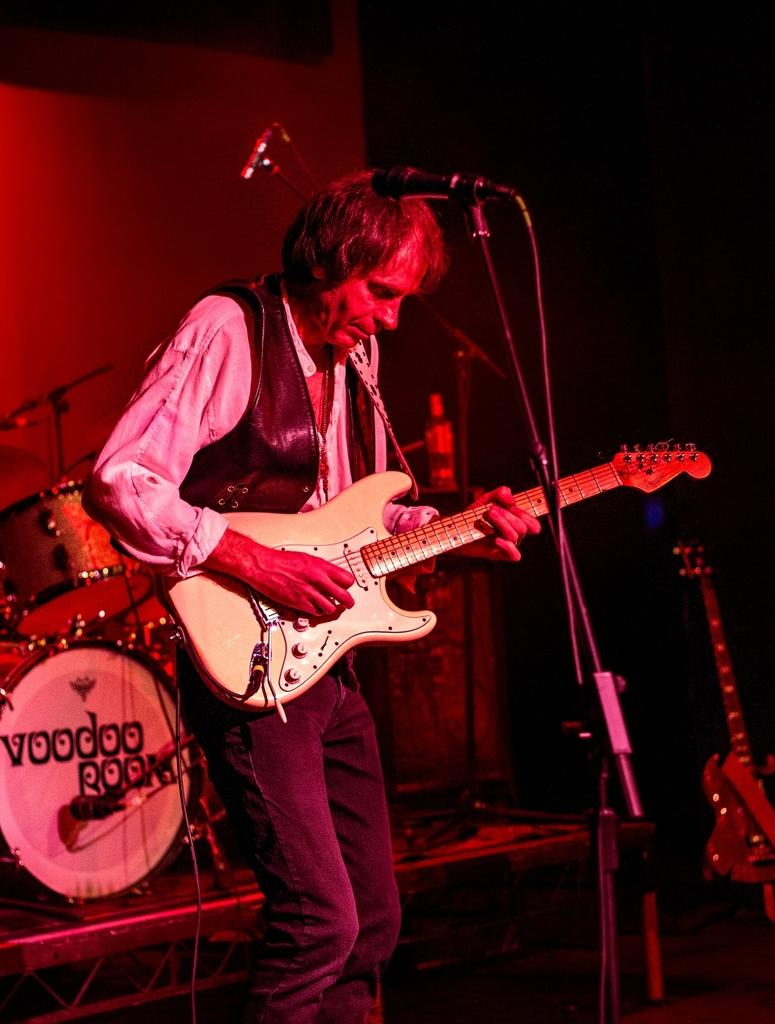Who is the main subject in the image? There is a man in the image. What is the man holding in the image? The man is holding a guitar. What is in front of the man in the image? There is a microphone with a mic holder in front of the man. What can be seen in the background of the image? There are musical instruments in the background of the image. What type of rail can be seen in the image? There is no rail present in the image. How does the ray of light affect the man's performance in the image? There is no ray of light mentioned or visible in the image. 